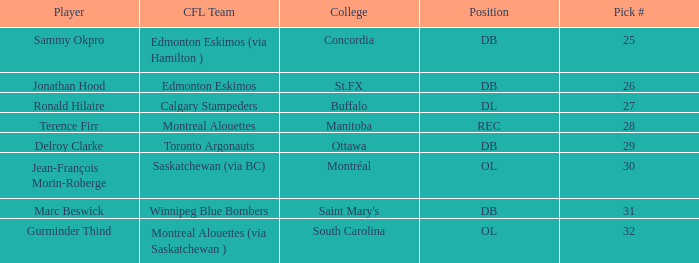In which college is the pick # more than 30, with a position of ol? South Carolina. 